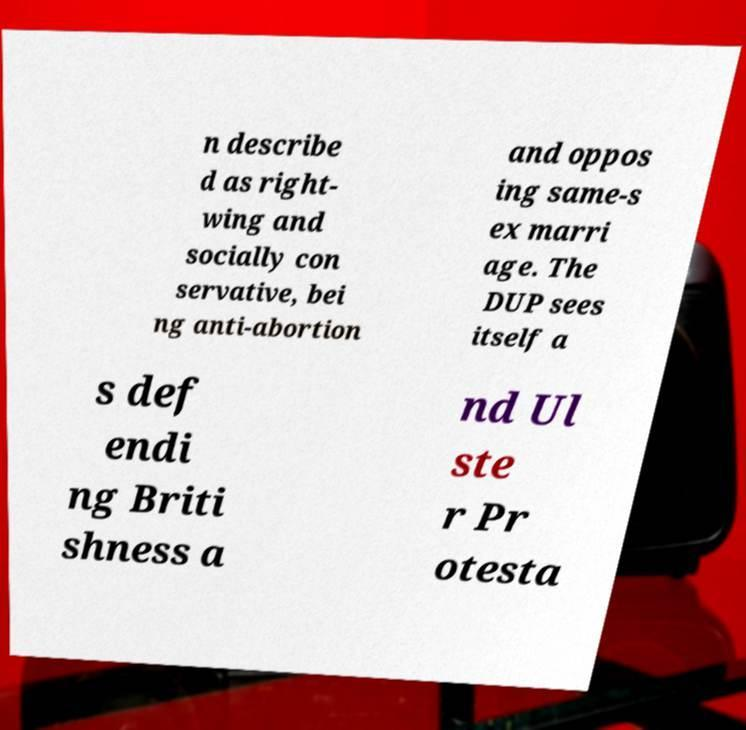Could you assist in decoding the text presented in this image and type it out clearly? n describe d as right- wing and socially con servative, bei ng anti-abortion and oppos ing same-s ex marri age. The DUP sees itself a s def endi ng Briti shness a nd Ul ste r Pr otesta 